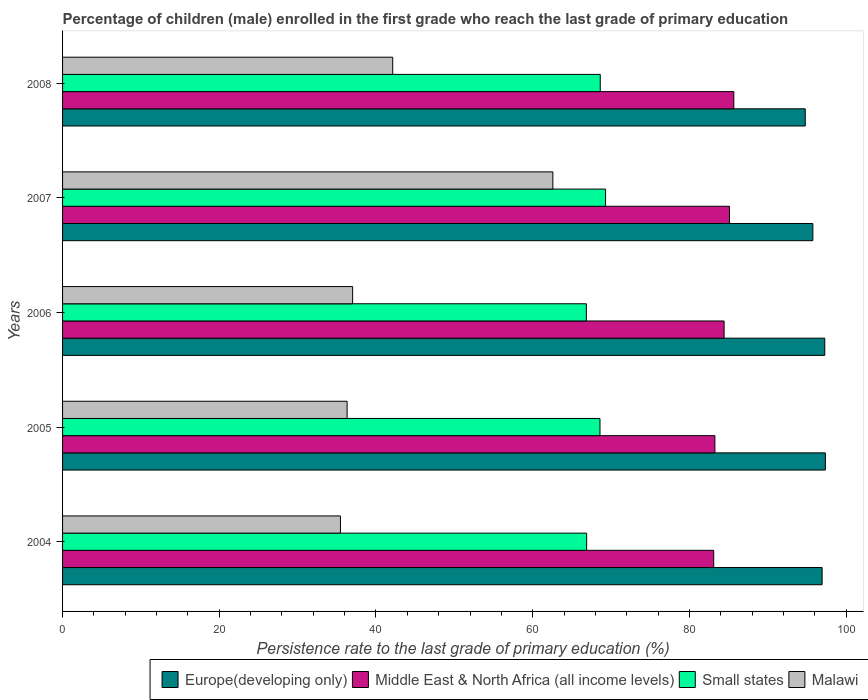How many different coloured bars are there?
Offer a very short reply. 4. How many groups of bars are there?
Give a very brief answer. 5. Are the number of bars on each tick of the Y-axis equal?
Your answer should be very brief. Yes. What is the label of the 1st group of bars from the top?
Your answer should be compact. 2008. In how many cases, is the number of bars for a given year not equal to the number of legend labels?
Make the answer very short. 0. What is the persistence rate of children in Europe(developing only) in 2007?
Provide a succinct answer. 95.75. Across all years, what is the maximum persistence rate of children in Middle East & North Africa (all income levels)?
Make the answer very short. 85.67. Across all years, what is the minimum persistence rate of children in Middle East & North Africa (all income levels)?
Your answer should be compact. 83.1. In which year was the persistence rate of children in Middle East & North Africa (all income levels) minimum?
Offer a terse response. 2004. What is the total persistence rate of children in Malawi in the graph?
Your response must be concise. 213.5. What is the difference between the persistence rate of children in Europe(developing only) in 2005 and that in 2006?
Provide a succinct answer. 0.07. What is the difference between the persistence rate of children in Malawi in 2006 and the persistence rate of children in Middle East & North Africa (all income levels) in 2008?
Make the answer very short. -48.65. What is the average persistence rate of children in Middle East & North Africa (all income levels) per year?
Offer a terse response. 84.31. In the year 2004, what is the difference between the persistence rate of children in Europe(developing only) and persistence rate of children in Small states?
Keep it short and to the point. 30.05. What is the ratio of the persistence rate of children in Malawi in 2004 to that in 2005?
Keep it short and to the point. 0.98. What is the difference between the highest and the second highest persistence rate of children in Small states?
Your response must be concise. 0.68. What is the difference between the highest and the lowest persistence rate of children in Malawi?
Ensure brevity in your answer.  27.11. In how many years, is the persistence rate of children in Small states greater than the average persistence rate of children in Small states taken over all years?
Your answer should be very brief. 3. Is the sum of the persistence rate of children in Small states in 2006 and 2008 greater than the maximum persistence rate of children in Malawi across all years?
Your response must be concise. Yes. What does the 3rd bar from the top in 2004 represents?
Offer a very short reply. Middle East & North Africa (all income levels). What does the 3rd bar from the bottom in 2008 represents?
Ensure brevity in your answer.  Small states. Are all the bars in the graph horizontal?
Your answer should be very brief. Yes. Does the graph contain any zero values?
Make the answer very short. No. How many legend labels are there?
Provide a short and direct response. 4. What is the title of the graph?
Provide a succinct answer. Percentage of children (male) enrolled in the first grade who reach the last grade of primary education. What is the label or title of the X-axis?
Offer a terse response. Persistence rate to the last grade of primary education (%). What is the label or title of the Y-axis?
Your response must be concise. Years. What is the Persistence rate to the last grade of primary education (%) in Europe(developing only) in 2004?
Provide a succinct answer. 96.94. What is the Persistence rate to the last grade of primary education (%) of Middle East & North Africa (all income levels) in 2004?
Provide a short and direct response. 83.1. What is the Persistence rate to the last grade of primary education (%) of Small states in 2004?
Provide a succinct answer. 66.88. What is the Persistence rate to the last grade of primary education (%) in Malawi in 2004?
Your answer should be very brief. 35.46. What is the Persistence rate to the last grade of primary education (%) in Europe(developing only) in 2005?
Offer a terse response. 97.35. What is the Persistence rate to the last grade of primary education (%) in Middle East & North Africa (all income levels) in 2005?
Give a very brief answer. 83.25. What is the Persistence rate to the last grade of primary education (%) in Small states in 2005?
Your answer should be compact. 68.59. What is the Persistence rate to the last grade of primary education (%) in Malawi in 2005?
Give a very brief answer. 36.31. What is the Persistence rate to the last grade of primary education (%) in Europe(developing only) in 2006?
Your response must be concise. 97.27. What is the Persistence rate to the last grade of primary education (%) of Middle East & North Africa (all income levels) in 2006?
Offer a very short reply. 84.43. What is the Persistence rate to the last grade of primary education (%) in Small states in 2006?
Keep it short and to the point. 66.85. What is the Persistence rate to the last grade of primary education (%) of Malawi in 2006?
Provide a short and direct response. 37.02. What is the Persistence rate to the last grade of primary education (%) in Europe(developing only) in 2007?
Offer a terse response. 95.75. What is the Persistence rate to the last grade of primary education (%) of Middle East & North Africa (all income levels) in 2007?
Ensure brevity in your answer.  85.11. What is the Persistence rate to the last grade of primary education (%) in Small states in 2007?
Provide a succinct answer. 69.3. What is the Persistence rate to the last grade of primary education (%) of Malawi in 2007?
Your answer should be compact. 62.57. What is the Persistence rate to the last grade of primary education (%) of Europe(developing only) in 2008?
Ensure brevity in your answer.  94.78. What is the Persistence rate to the last grade of primary education (%) of Middle East & North Africa (all income levels) in 2008?
Offer a very short reply. 85.67. What is the Persistence rate to the last grade of primary education (%) of Small states in 2008?
Your answer should be very brief. 68.62. What is the Persistence rate to the last grade of primary education (%) in Malawi in 2008?
Keep it short and to the point. 42.13. Across all years, what is the maximum Persistence rate to the last grade of primary education (%) of Europe(developing only)?
Provide a short and direct response. 97.35. Across all years, what is the maximum Persistence rate to the last grade of primary education (%) in Middle East & North Africa (all income levels)?
Offer a very short reply. 85.67. Across all years, what is the maximum Persistence rate to the last grade of primary education (%) of Small states?
Your response must be concise. 69.3. Across all years, what is the maximum Persistence rate to the last grade of primary education (%) in Malawi?
Offer a very short reply. 62.57. Across all years, what is the minimum Persistence rate to the last grade of primary education (%) of Europe(developing only)?
Provide a short and direct response. 94.78. Across all years, what is the minimum Persistence rate to the last grade of primary education (%) in Middle East & North Africa (all income levels)?
Provide a short and direct response. 83.1. Across all years, what is the minimum Persistence rate to the last grade of primary education (%) of Small states?
Your response must be concise. 66.85. Across all years, what is the minimum Persistence rate to the last grade of primary education (%) in Malawi?
Your answer should be very brief. 35.46. What is the total Persistence rate to the last grade of primary education (%) of Europe(developing only) in the graph?
Your answer should be very brief. 482.1. What is the total Persistence rate to the last grade of primary education (%) of Middle East & North Africa (all income levels) in the graph?
Offer a very short reply. 421.56. What is the total Persistence rate to the last grade of primary education (%) in Small states in the graph?
Offer a terse response. 340.24. What is the total Persistence rate to the last grade of primary education (%) in Malawi in the graph?
Ensure brevity in your answer.  213.5. What is the difference between the Persistence rate to the last grade of primary education (%) in Europe(developing only) in 2004 and that in 2005?
Give a very brief answer. -0.41. What is the difference between the Persistence rate to the last grade of primary education (%) in Middle East & North Africa (all income levels) in 2004 and that in 2005?
Make the answer very short. -0.15. What is the difference between the Persistence rate to the last grade of primary education (%) in Small states in 2004 and that in 2005?
Ensure brevity in your answer.  -1.7. What is the difference between the Persistence rate to the last grade of primary education (%) in Malawi in 2004 and that in 2005?
Provide a short and direct response. -0.85. What is the difference between the Persistence rate to the last grade of primary education (%) of Europe(developing only) in 2004 and that in 2006?
Ensure brevity in your answer.  -0.34. What is the difference between the Persistence rate to the last grade of primary education (%) of Middle East & North Africa (all income levels) in 2004 and that in 2006?
Keep it short and to the point. -1.33. What is the difference between the Persistence rate to the last grade of primary education (%) in Small states in 2004 and that in 2006?
Make the answer very short. 0.04. What is the difference between the Persistence rate to the last grade of primary education (%) in Malawi in 2004 and that in 2006?
Provide a short and direct response. -1.56. What is the difference between the Persistence rate to the last grade of primary education (%) in Europe(developing only) in 2004 and that in 2007?
Provide a succinct answer. 1.18. What is the difference between the Persistence rate to the last grade of primary education (%) of Middle East & North Africa (all income levels) in 2004 and that in 2007?
Your answer should be very brief. -2.01. What is the difference between the Persistence rate to the last grade of primary education (%) in Small states in 2004 and that in 2007?
Keep it short and to the point. -2.42. What is the difference between the Persistence rate to the last grade of primary education (%) in Malawi in 2004 and that in 2007?
Ensure brevity in your answer.  -27.11. What is the difference between the Persistence rate to the last grade of primary education (%) in Europe(developing only) in 2004 and that in 2008?
Ensure brevity in your answer.  2.15. What is the difference between the Persistence rate to the last grade of primary education (%) of Middle East & North Africa (all income levels) in 2004 and that in 2008?
Offer a terse response. -2.57. What is the difference between the Persistence rate to the last grade of primary education (%) of Small states in 2004 and that in 2008?
Your answer should be compact. -1.74. What is the difference between the Persistence rate to the last grade of primary education (%) of Malawi in 2004 and that in 2008?
Give a very brief answer. -6.67. What is the difference between the Persistence rate to the last grade of primary education (%) in Europe(developing only) in 2005 and that in 2006?
Your answer should be very brief. 0.07. What is the difference between the Persistence rate to the last grade of primary education (%) of Middle East & North Africa (all income levels) in 2005 and that in 2006?
Provide a short and direct response. -1.18. What is the difference between the Persistence rate to the last grade of primary education (%) of Small states in 2005 and that in 2006?
Your response must be concise. 1.74. What is the difference between the Persistence rate to the last grade of primary education (%) of Malawi in 2005 and that in 2006?
Provide a succinct answer. -0.71. What is the difference between the Persistence rate to the last grade of primary education (%) in Europe(developing only) in 2005 and that in 2007?
Provide a succinct answer. 1.59. What is the difference between the Persistence rate to the last grade of primary education (%) of Middle East & North Africa (all income levels) in 2005 and that in 2007?
Offer a very short reply. -1.86. What is the difference between the Persistence rate to the last grade of primary education (%) of Small states in 2005 and that in 2007?
Your answer should be compact. -0.71. What is the difference between the Persistence rate to the last grade of primary education (%) in Malawi in 2005 and that in 2007?
Ensure brevity in your answer.  -26.26. What is the difference between the Persistence rate to the last grade of primary education (%) in Europe(developing only) in 2005 and that in 2008?
Keep it short and to the point. 2.56. What is the difference between the Persistence rate to the last grade of primary education (%) of Middle East & North Africa (all income levels) in 2005 and that in 2008?
Keep it short and to the point. -2.41. What is the difference between the Persistence rate to the last grade of primary education (%) of Small states in 2005 and that in 2008?
Your answer should be very brief. -0.03. What is the difference between the Persistence rate to the last grade of primary education (%) of Malawi in 2005 and that in 2008?
Keep it short and to the point. -5.82. What is the difference between the Persistence rate to the last grade of primary education (%) in Europe(developing only) in 2006 and that in 2007?
Keep it short and to the point. 1.52. What is the difference between the Persistence rate to the last grade of primary education (%) of Middle East & North Africa (all income levels) in 2006 and that in 2007?
Provide a short and direct response. -0.68. What is the difference between the Persistence rate to the last grade of primary education (%) in Small states in 2006 and that in 2007?
Offer a very short reply. -2.45. What is the difference between the Persistence rate to the last grade of primary education (%) of Malawi in 2006 and that in 2007?
Your answer should be compact. -25.55. What is the difference between the Persistence rate to the last grade of primary education (%) of Europe(developing only) in 2006 and that in 2008?
Offer a very short reply. 2.49. What is the difference between the Persistence rate to the last grade of primary education (%) in Middle East & North Africa (all income levels) in 2006 and that in 2008?
Your answer should be compact. -1.24. What is the difference between the Persistence rate to the last grade of primary education (%) in Small states in 2006 and that in 2008?
Ensure brevity in your answer.  -1.77. What is the difference between the Persistence rate to the last grade of primary education (%) in Malawi in 2006 and that in 2008?
Provide a succinct answer. -5.11. What is the difference between the Persistence rate to the last grade of primary education (%) in Europe(developing only) in 2007 and that in 2008?
Give a very brief answer. 0.97. What is the difference between the Persistence rate to the last grade of primary education (%) in Middle East & North Africa (all income levels) in 2007 and that in 2008?
Offer a very short reply. -0.55. What is the difference between the Persistence rate to the last grade of primary education (%) of Small states in 2007 and that in 2008?
Offer a very short reply. 0.68. What is the difference between the Persistence rate to the last grade of primary education (%) of Malawi in 2007 and that in 2008?
Offer a very short reply. 20.44. What is the difference between the Persistence rate to the last grade of primary education (%) of Europe(developing only) in 2004 and the Persistence rate to the last grade of primary education (%) of Middle East & North Africa (all income levels) in 2005?
Ensure brevity in your answer.  13.68. What is the difference between the Persistence rate to the last grade of primary education (%) in Europe(developing only) in 2004 and the Persistence rate to the last grade of primary education (%) in Small states in 2005?
Ensure brevity in your answer.  28.35. What is the difference between the Persistence rate to the last grade of primary education (%) of Europe(developing only) in 2004 and the Persistence rate to the last grade of primary education (%) of Malawi in 2005?
Provide a short and direct response. 60.62. What is the difference between the Persistence rate to the last grade of primary education (%) of Middle East & North Africa (all income levels) in 2004 and the Persistence rate to the last grade of primary education (%) of Small states in 2005?
Offer a terse response. 14.51. What is the difference between the Persistence rate to the last grade of primary education (%) of Middle East & North Africa (all income levels) in 2004 and the Persistence rate to the last grade of primary education (%) of Malawi in 2005?
Provide a succinct answer. 46.79. What is the difference between the Persistence rate to the last grade of primary education (%) of Small states in 2004 and the Persistence rate to the last grade of primary education (%) of Malawi in 2005?
Give a very brief answer. 30.57. What is the difference between the Persistence rate to the last grade of primary education (%) in Europe(developing only) in 2004 and the Persistence rate to the last grade of primary education (%) in Middle East & North Africa (all income levels) in 2006?
Ensure brevity in your answer.  12.51. What is the difference between the Persistence rate to the last grade of primary education (%) in Europe(developing only) in 2004 and the Persistence rate to the last grade of primary education (%) in Small states in 2006?
Make the answer very short. 30.09. What is the difference between the Persistence rate to the last grade of primary education (%) in Europe(developing only) in 2004 and the Persistence rate to the last grade of primary education (%) in Malawi in 2006?
Ensure brevity in your answer.  59.92. What is the difference between the Persistence rate to the last grade of primary education (%) of Middle East & North Africa (all income levels) in 2004 and the Persistence rate to the last grade of primary education (%) of Small states in 2006?
Your response must be concise. 16.25. What is the difference between the Persistence rate to the last grade of primary education (%) of Middle East & North Africa (all income levels) in 2004 and the Persistence rate to the last grade of primary education (%) of Malawi in 2006?
Your answer should be very brief. 46.08. What is the difference between the Persistence rate to the last grade of primary education (%) in Small states in 2004 and the Persistence rate to the last grade of primary education (%) in Malawi in 2006?
Your answer should be compact. 29.86. What is the difference between the Persistence rate to the last grade of primary education (%) in Europe(developing only) in 2004 and the Persistence rate to the last grade of primary education (%) in Middle East & North Africa (all income levels) in 2007?
Your answer should be very brief. 11.82. What is the difference between the Persistence rate to the last grade of primary education (%) of Europe(developing only) in 2004 and the Persistence rate to the last grade of primary education (%) of Small states in 2007?
Keep it short and to the point. 27.64. What is the difference between the Persistence rate to the last grade of primary education (%) in Europe(developing only) in 2004 and the Persistence rate to the last grade of primary education (%) in Malawi in 2007?
Provide a short and direct response. 34.36. What is the difference between the Persistence rate to the last grade of primary education (%) in Middle East & North Africa (all income levels) in 2004 and the Persistence rate to the last grade of primary education (%) in Small states in 2007?
Offer a terse response. 13.8. What is the difference between the Persistence rate to the last grade of primary education (%) in Middle East & North Africa (all income levels) in 2004 and the Persistence rate to the last grade of primary education (%) in Malawi in 2007?
Provide a succinct answer. 20.53. What is the difference between the Persistence rate to the last grade of primary education (%) in Small states in 2004 and the Persistence rate to the last grade of primary education (%) in Malawi in 2007?
Your answer should be compact. 4.31. What is the difference between the Persistence rate to the last grade of primary education (%) in Europe(developing only) in 2004 and the Persistence rate to the last grade of primary education (%) in Middle East & North Africa (all income levels) in 2008?
Your response must be concise. 11.27. What is the difference between the Persistence rate to the last grade of primary education (%) of Europe(developing only) in 2004 and the Persistence rate to the last grade of primary education (%) of Small states in 2008?
Give a very brief answer. 28.32. What is the difference between the Persistence rate to the last grade of primary education (%) of Europe(developing only) in 2004 and the Persistence rate to the last grade of primary education (%) of Malawi in 2008?
Make the answer very short. 54.8. What is the difference between the Persistence rate to the last grade of primary education (%) of Middle East & North Africa (all income levels) in 2004 and the Persistence rate to the last grade of primary education (%) of Small states in 2008?
Offer a terse response. 14.48. What is the difference between the Persistence rate to the last grade of primary education (%) of Middle East & North Africa (all income levels) in 2004 and the Persistence rate to the last grade of primary education (%) of Malawi in 2008?
Your response must be concise. 40.97. What is the difference between the Persistence rate to the last grade of primary education (%) in Small states in 2004 and the Persistence rate to the last grade of primary education (%) in Malawi in 2008?
Offer a very short reply. 24.75. What is the difference between the Persistence rate to the last grade of primary education (%) in Europe(developing only) in 2005 and the Persistence rate to the last grade of primary education (%) in Middle East & North Africa (all income levels) in 2006?
Your answer should be very brief. 12.92. What is the difference between the Persistence rate to the last grade of primary education (%) in Europe(developing only) in 2005 and the Persistence rate to the last grade of primary education (%) in Small states in 2006?
Make the answer very short. 30.5. What is the difference between the Persistence rate to the last grade of primary education (%) of Europe(developing only) in 2005 and the Persistence rate to the last grade of primary education (%) of Malawi in 2006?
Ensure brevity in your answer.  60.33. What is the difference between the Persistence rate to the last grade of primary education (%) of Middle East & North Africa (all income levels) in 2005 and the Persistence rate to the last grade of primary education (%) of Small states in 2006?
Offer a very short reply. 16.4. What is the difference between the Persistence rate to the last grade of primary education (%) in Middle East & North Africa (all income levels) in 2005 and the Persistence rate to the last grade of primary education (%) in Malawi in 2006?
Offer a terse response. 46.23. What is the difference between the Persistence rate to the last grade of primary education (%) in Small states in 2005 and the Persistence rate to the last grade of primary education (%) in Malawi in 2006?
Provide a short and direct response. 31.57. What is the difference between the Persistence rate to the last grade of primary education (%) in Europe(developing only) in 2005 and the Persistence rate to the last grade of primary education (%) in Middle East & North Africa (all income levels) in 2007?
Offer a very short reply. 12.24. What is the difference between the Persistence rate to the last grade of primary education (%) in Europe(developing only) in 2005 and the Persistence rate to the last grade of primary education (%) in Small states in 2007?
Make the answer very short. 28.05. What is the difference between the Persistence rate to the last grade of primary education (%) of Europe(developing only) in 2005 and the Persistence rate to the last grade of primary education (%) of Malawi in 2007?
Ensure brevity in your answer.  34.78. What is the difference between the Persistence rate to the last grade of primary education (%) of Middle East & North Africa (all income levels) in 2005 and the Persistence rate to the last grade of primary education (%) of Small states in 2007?
Your answer should be compact. 13.95. What is the difference between the Persistence rate to the last grade of primary education (%) in Middle East & North Africa (all income levels) in 2005 and the Persistence rate to the last grade of primary education (%) in Malawi in 2007?
Offer a very short reply. 20.68. What is the difference between the Persistence rate to the last grade of primary education (%) of Small states in 2005 and the Persistence rate to the last grade of primary education (%) of Malawi in 2007?
Provide a succinct answer. 6.01. What is the difference between the Persistence rate to the last grade of primary education (%) in Europe(developing only) in 2005 and the Persistence rate to the last grade of primary education (%) in Middle East & North Africa (all income levels) in 2008?
Keep it short and to the point. 11.68. What is the difference between the Persistence rate to the last grade of primary education (%) in Europe(developing only) in 2005 and the Persistence rate to the last grade of primary education (%) in Small states in 2008?
Your answer should be compact. 28.73. What is the difference between the Persistence rate to the last grade of primary education (%) in Europe(developing only) in 2005 and the Persistence rate to the last grade of primary education (%) in Malawi in 2008?
Provide a succinct answer. 55.21. What is the difference between the Persistence rate to the last grade of primary education (%) in Middle East & North Africa (all income levels) in 2005 and the Persistence rate to the last grade of primary education (%) in Small states in 2008?
Offer a very short reply. 14.63. What is the difference between the Persistence rate to the last grade of primary education (%) of Middle East & North Africa (all income levels) in 2005 and the Persistence rate to the last grade of primary education (%) of Malawi in 2008?
Your answer should be compact. 41.12. What is the difference between the Persistence rate to the last grade of primary education (%) of Small states in 2005 and the Persistence rate to the last grade of primary education (%) of Malawi in 2008?
Keep it short and to the point. 26.45. What is the difference between the Persistence rate to the last grade of primary education (%) of Europe(developing only) in 2006 and the Persistence rate to the last grade of primary education (%) of Middle East & North Africa (all income levels) in 2007?
Offer a very short reply. 12.16. What is the difference between the Persistence rate to the last grade of primary education (%) in Europe(developing only) in 2006 and the Persistence rate to the last grade of primary education (%) in Small states in 2007?
Make the answer very short. 27.98. What is the difference between the Persistence rate to the last grade of primary education (%) of Europe(developing only) in 2006 and the Persistence rate to the last grade of primary education (%) of Malawi in 2007?
Your answer should be compact. 34.7. What is the difference between the Persistence rate to the last grade of primary education (%) of Middle East & North Africa (all income levels) in 2006 and the Persistence rate to the last grade of primary education (%) of Small states in 2007?
Offer a very short reply. 15.13. What is the difference between the Persistence rate to the last grade of primary education (%) of Middle East & North Africa (all income levels) in 2006 and the Persistence rate to the last grade of primary education (%) of Malawi in 2007?
Make the answer very short. 21.86. What is the difference between the Persistence rate to the last grade of primary education (%) in Small states in 2006 and the Persistence rate to the last grade of primary education (%) in Malawi in 2007?
Make the answer very short. 4.27. What is the difference between the Persistence rate to the last grade of primary education (%) in Europe(developing only) in 2006 and the Persistence rate to the last grade of primary education (%) in Middle East & North Africa (all income levels) in 2008?
Your answer should be compact. 11.61. What is the difference between the Persistence rate to the last grade of primary education (%) in Europe(developing only) in 2006 and the Persistence rate to the last grade of primary education (%) in Small states in 2008?
Your response must be concise. 28.65. What is the difference between the Persistence rate to the last grade of primary education (%) in Europe(developing only) in 2006 and the Persistence rate to the last grade of primary education (%) in Malawi in 2008?
Your response must be concise. 55.14. What is the difference between the Persistence rate to the last grade of primary education (%) of Middle East & North Africa (all income levels) in 2006 and the Persistence rate to the last grade of primary education (%) of Small states in 2008?
Your answer should be very brief. 15.81. What is the difference between the Persistence rate to the last grade of primary education (%) of Middle East & North Africa (all income levels) in 2006 and the Persistence rate to the last grade of primary education (%) of Malawi in 2008?
Ensure brevity in your answer.  42.29. What is the difference between the Persistence rate to the last grade of primary education (%) in Small states in 2006 and the Persistence rate to the last grade of primary education (%) in Malawi in 2008?
Your answer should be compact. 24.71. What is the difference between the Persistence rate to the last grade of primary education (%) of Europe(developing only) in 2007 and the Persistence rate to the last grade of primary education (%) of Middle East & North Africa (all income levels) in 2008?
Your response must be concise. 10.09. What is the difference between the Persistence rate to the last grade of primary education (%) of Europe(developing only) in 2007 and the Persistence rate to the last grade of primary education (%) of Small states in 2008?
Ensure brevity in your answer.  27.13. What is the difference between the Persistence rate to the last grade of primary education (%) in Europe(developing only) in 2007 and the Persistence rate to the last grade of primary education (%) in Malawi in 2008?
Provide a succinct answer. 53.62. What is the difference between the Persistence rate to the last grade of primary education (%) of Middle East & North Africa (all income levels) in 2007 and the Persistence rate to the last grade of primary education (%) of Small states in 2008?
Ensure brevity in your answer.  16.49. What is the difference between the Persistence rate to the last grade of primary education (%) of Middle East & North Africa (all income levels) in 2007 and the Persistence rate to the last grade of primary education (%) of Malawi in 2008?
Provide a short and direct response. 42.98. What is the difference between the Persistence rate to the last grade of primary education (%) in Small states in 2007 and the Persistence rate to the last grade of primary education (%) in Malawi in 2008?
Your response must be concise. 27.16. What is the average Persistence rate to the last grade of primary education (%) of Europe(developing only) per year?
Your answer should be compact. 96.42. What is the average Persistence rate to the last grade of primary education (%) of Middle East & North Africa (all income levels) per year?
Provide a succinct answer. 84.31. What is the average Persistence rate to the last grade of primary education (%) of Small states per year?
Your answer should be compact. 68.05. What is the average Persistence rate to the last grade of primary education (%) in Malawi per year?
Your response must be concise. 42.7. In the year 2004, what is the difference between the Persistence rate to the last grade of primary education (%) in Europe(developing only) and Persistence rate to the last grade of primary education (%) in Middle East & North Africa (all income levels)?
Keep it short and to the point. 13.84. In the year 2004, what is the difference between the Persistence rate to the last grade of primary education (%) of Europe(developing only) and Persistence rate to the last grade of primary education (%) of Small states?
Provide a succinct answer. 30.05. In the year 2004, what is the difference between the Persistence rate to the last grade of primary education (%) of Europe(developing only) and Persistence rate to the last grade of primary education (%) of Malawi?
Your answer should be compact. 61.47. In the year 2004, what is the difference between the Persistence rate to the last grade of primary education (%) of Middle East & North Africa (all income levels) and Persistence rate to the last grade of primary education (%) of Small states?
Ensure brevity in your answer.  16.22. In the year 2004, what is the difference between the Persistence rate to the last grade of primary education (%) of Middle East & North Africa (all income levels) and Persistence rate to the last grade of primary education (%) of Malawi?
Your response must be concise. 47.64. In the year 2004, what is the difference between the Persistence rate to the last grade of primary education (%) in Small states and Persistence rate to the last grade of primary education (%) in Malawi?
Make the answer very short. 31.42. In the year 2005, what is the difference between the Persistence rate to the last grade of primary education (%) in Europe(developing only) and Persistence rate to the last grade of primary education (%) in Middle East & North Africa (all income levels)?
Keep it short and to the point. 14.1. In the year 2005, what is the difference between the Persistence rate to the last grade of primary education (%) of Europe(developing only) and Persistence rate to the last grade of primary education (%) of Small states?
Offer a very short reply. 28.76. In the year 2005, what is the difference between the Persistence rate to the last grade of primary education (%) of Europe(developing only) and Persistence rate to the last grade of primary education (%) of Malawi?
Provide a succinct answer. 61.04. In the year 2005, what is the difference between the Persistence rate to the last grade of primary education (%) in Middle East & North Africa (all income levels) and Persistence rate to the last grade of primary education (%) in Small states?
Make the answer very short. 14.66. In the year 2005, what is the difference between the Persistence rate to the last grade of primary education (%) in Middle East & North Africa (all income levels) and Persistence rate to the last grade of primary education (%) in Malawi?
Offer a terse response. 46.94. In the year 2005, what is the difference between the Persistence rate to the last grade of primary education (%) in Small states and Persistence rate to the last grade of primary education (%) in Malawi?
Your answer should be compact. 32.27. In the year 2006, what is the difference between the Persistence rate to the last grade of primary education (%) of Europe(developing only) and Persistence rate to the last grade of primary education (%) of Middle East & North Africa (all income levels)?
Ensure brevity in your answer.  12.85. In the year 2006, what is the difference between the Persistence rate to the last grade of primary education (%) of Europe(developing only) and Persistence rate to the last grade of primary education (%) of Small states?
Keep it short and to the point. 30.43. In the year 2006, what is the difference between the Persistence rate to the last grade of primary education (%) in Europe(developing only) and Persistence rate to the last grade of primary education (%) in Malawi?
Your response must be concise. 60.25. In the year 2006, what is the difference between the Persistence rate to the last grade of primary education (%) in Middle East & North Africa (all income levels) and Persistence rate to the last grade of primary education (%) in Small states?
Your answer should be very brief. 17.58. In the year 2006, what is the difference between the Persistence rate to the last grade of primary education (%) in Middle East & North Africa (all income levels) and Persistence rate to the last grade of primary education (%) in Malawi?
Ensure brevity in your answer.  47.41. In the year 2006, what is the difference between the Persistence rate to the last grade of primary education (%) in Small states and Persistence rate to the last grade of primary education (%) in Malawi?
Offer a very short reply. 29.83. In the year 2007, what is the difference between the Persistence rate to the last grade of primary education (%) of Europe(developing only) and Persistence rate to the last grade of primary education (%) of Middle East & North Africa (all income levels)?
Your response must be concise. 10.64. In the year 2007, what is the difference between the Persistence rate to the last grade of primary education (%) of Europe(developing only) and Persistence rate to the last grade of primary education (%) of Small states?
Offer a very short reply. 26.46. In the year 2007, what is the difference between the Persistence rate to the last grade of primary education (%) in Europe(developing only) and Persistence rate to the last grade of primary education (%) in Malawi?
Your response must be concise. 33.18. In the year 2007, what is the difference between the Persistence rate to the last grade of primary education (%) in Middle East & North Africa (all income levels) and Persistence rate to the last grade of primary education (%) in Small states?
Keep it short and to the point. 15.81. In the year 2007, what is the difference between the Persistence rate to the last grade of primary education (%) in Middle East & North Africa (all income levels) and Persistence rate to the last grade of primary education (%) in Malawi?
Your answer should be compact. 22.54. In the year 2007, what is the difference between the Persistence rate to the last grade of primary education (%) in Small states and Persistence rate to the last grade of primary education (%) in Malawi?
Make the answer very short. 6.73. In the year 2008, what is the difference between the Persistence rate to the last grade of primary education (%) of Europe(developing only) and Persistence rate to the last grade of primary education (%) of Middle East & North Africa (all income levels)?
Provide a short and direct response. 9.12. In the year 2008, what is the difference between the Persistence rate to the last grade of primary education (%) of Europe(developing only) and Persistence rate to the last grade of primary education (%) of Small states?
Your response must be concise. 26.16. In the year 2008, what is the difference between the Persistence rate to the last grade of primary education (%) in Europe(developing only) and Persistence rate to the last grade of primary education (%) in Malawi?
Your answer should be very brief. 52.65. In the year 2008, what is the difference between the Persistence rate to the last grade of primary education (%) in Middle East & North Africa (all income levels) and Persistence rate to the last grade of primary education (%) in Small states?
Your answer should be very brief. 17.05. In the year 2008, what is the difference between the Persistence rate to the last grade of primary education (%) of Middle East & North Africa (all income levels) and Persistence rate to the last grade of primary education (%) of Malawi?
Keep it short and to the point. 43.53. In the year 2008, what is the difference between the Persistence rate to the last grade of primary education (%) in Small states and Persistence rate to the last grade of primary education (%) in Malawi?
Provide a succinct answer. 26.49. What is the ratio of the Persistence rate to the last grade of primary education (%) in Europe(developing only) in 2004 to that in 2005?
Your answer should be very brief. 1. What is the ratio of the Persistence rate to the last grade of primary education (%) of Middle East & North Africa (all income levels) in 2004 to that in 2005?
Make the answer very short. 1. What is the ratio of the Persistence rate to the last grade of primary education (%) in Small states in 2004 to that in 2005?
Your answer should be compact. 0.98. What is the ratio of the Persistence rate to the last grade of primary education (%) of Malawi in 2004 to that in 2005?
Keep it short and to the point. 0.98. What is the ratio of the Persistence rate to the last grade of primary education (%) of Europe(developing only) in 2004 to that in 2006?
Offer a very short reply. 1. What is the ratio of the Persistence rate to the last grade of primary education (%) in Middle East & North Africa (all income levels) in 2004 to that in 2006?
Give a very brief answer. 0.98. What is the ratio of the Persistence rate to the last grade of primary education (%) of Small states in 2004 to that in 2006?
Provide a short and direct response. 1. What is the ratio of the Persistence rate to the last grade of primary education (%) in Malawi in 2004 to that in 2006?
Make the answer very short. 0.96. What is the ratio of the Persistence rate to the last grade of primary education (%) in Europe(developing only) in 2004 to that in 2007?
Your answer should be very brief. 1.01. What is the ratio of the Persistence rate to the last grade of primary education (%) of Middle East & North Africa (all income levels) in 2004 to that in 2007?
Make the answer very short. 0.98. What is the ratio of the Persistence rate to the last grade of primary education (%) in Small states in 2004 to that in 2007?
Ensure brevity in your answer.  0.97. What is the ratio of the Persistence rate to the last grade of primary education (%) in Malawi in 2004 to that in 2007?
Provide a succinct answer. 0.57. What is the ratio of the Persistence rate to the last grade of primary education (%) in Europe(developing only) in 2004 to that in 2008?
Offer a very short reply. 1.02. What is the ratio of the Persistence rate to the last grade of primary education (%) of Small states in 2004 to that in 2008?
Provide a short and direct response. 0.97. What is the ratio of the Persistence rate to the last grade of primary education (%) in Malawi in 2004 to that in 2008?
Offer a terse response. 0.84. What is the ratio of the Persistence rate to the last grade of primary education (%) of Middle East & North Africa (all income levels) in 2005 to that in 2006?
Provide a succinct answer. 0.99. What is the ratio of the Persistence rate to the last grade of primary education (%) of Malawi in 2005 to that in 2006?
Ensure brevity in your answer.  0.98. What is the ratio of the Persistence rate to the last grade of primary education (%) in Europe(developing only) in 2005 to that in 2007?
Offer a terse response. 1.02. What is the ratio of the Persistence rate to the last grade of primary education (%) of Middle East & North Africa (all income levels) in 2005 to that in 2007?
Provide a short and direct response. 0.98. What is the ratio of the Persistence rate to the last grade of primary education (%) of Small states in 2005 to that in 2007?
Your response must be concise. 0.99. What is the ratio of the Persistence rate to the last grade of primary education (%) of Malawi in 2005 to that in 2007?
Offer a very short reply. 0.58. What is the ratio of the Persistence rate to the last grade of primary education (%) of Europe(developing only) in 2005 to that in 2008?
Provide a succinct answer. 1.03. What is the ratio of the Persistence rate to the last grade of primary education (%) of Middle East & North Africa (all income levels) in 2005 to that in 2008?
Provide a succinct answer. 0.97. What is the ratio of the Persistence rate to the last grade of primary education (%) in Malawi in 2005 to that in 2008?
Give a very brief answer. 0.86. What is the ratio of the Persistence rate to the last grade of primary education (%) of Europe(developing only) in 2006 to that in 2007?
Give a very brief answer. 1.02. What is the ratio of the Persistence rate to the last grade of primary education (%) in Small states in 2006 to that in 2007?
Provide a succinct answer. 0.96. What is the ratio of the Persistence rate to the last grade of primary education (%) in Malawi in 2006 to that in 2007?
Offer a terse response. 0.59. What is the ratio of the Persistence rate to the last grade of primary education (%) of Europe(developing only) in 2006 to that in 2008?
Make the answer very short. 1.03. What is the ratio of the Persistence rate to the last grade of primary education (%) in Middle East & North Africa (all income levels) in 2006 to that in 2008?
Your answer should be very brief. 0.99. What is the ratio of the Persistence rate to the last grade of primary education (%) in Small states in 2006 to that in 2008?
Ensure brevity in your answer.  0.97. What is the ratio of the Persistence rate to the last grade of primary education (%) in Malawi in 2006 to that in 2008?
Your answer should be very brief. 0.88. What is the ratio of the Persistence rate to the last grade of primary education (%) of Europe(developing only) in 2007 to that in 2008?
Provide a short and direct response. 1.01. What is the ratio of the Persistence rate to the last grade of primary education (%) in Middle East & North Africa (all income levels) in 2007 to that in 2008?
Your answer should be very brief. 0.99. What is the ratio of the Persistence rate to the last grade of primary education (%) of Small states in 2007 to that in 2008?
Ensure brevity in your answer.  1.01. What is the ratio of the Persistence rate to the last grade of primary education (%) of Malawi in 2007 to that in 2008?
Make the answer very short. 1.49. What is the difference between the highest and the second highest Persistence rate to the last grade of primary education (%) of Europe(developing only)?
Make the answer very short. 0.07. What is the difference between the highest and the second highest Persistence rate to the last grade of primary education (%) in Middle East & North Africa (all income levels)?
Give a very brief answer. 0.55. What is the difference between the highest and the second highest Persistence rate to the last grade of primary education (%) of Small states?
Give a very brief answer. 0.68. What is the difference between the highest and the second highest Persistence rate to the last grade of primary education (%) in Malawi?
Provide a short and direct response. 20.44. What is the difference between the highest and the lowest Persistence rate to the last grade of primary education (%) of Europe(developing only)?
Your answer should be compact. 2.56. What is the difference between the highest and the lowest Persistence rate to the last grade of primary education (%) of Middle East & North Africa (all income levels)?
Your answer should be very brief. 2.57. What is the difference between the highest and the lowest Persistence rate to the last grade of primary education (%) in Small states?
Provide a short and direct response. 2.45. What is the difference between the highest and the lowest Persistence rate to the last grade of primary education (%) in Malawi?
Your answer should be very brief. 27.11. 